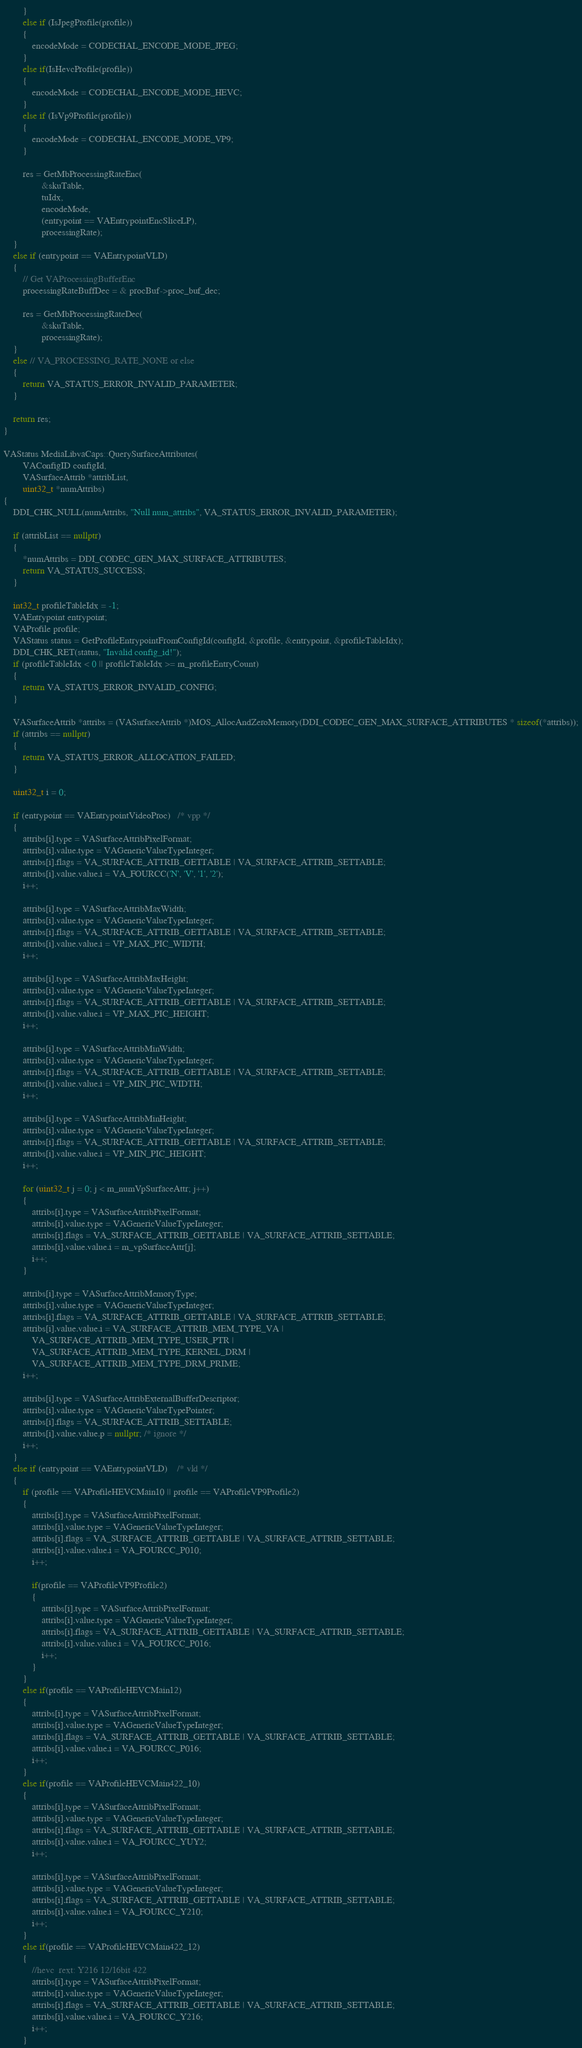Convert code to text. <code><loc_0><loc_0><loc_500><loc_500><_C++_>        }
        else if (IsJpegProfile(profile))
        {
            encodeMode = CODECHAL_ENCODE_MODE_JPEG;
        }
        else if(IsHevcProfile(profile))
        {
            encodeMode = CODECHAL_ENCODE_MODE_HEVC;
        }
        else if (IsVp9Profile(profile))
        {
            encodeMode = CODECHAL_ENCODE_MODE_VP9;
        }

        res = GetMbProcessingRateEnc(
                &skuTable,
                tuIdx,
                encodeMode,
                (entrypoint == VAEntrypointEncSliceLP),
                processingRate);
    }
    else if (entrypoint == VAEntrypointVLD)
    {
        // Get VAProcessingBufferEnc
        processingRateBuffDec = & procBuf->proc_buf_dec;

        res = GetMbProcessingRateDec(
                &skuTable,
                processingRate);
    }
    else // VA_PROCESSING_RATE_NONE or else
    {
        return VA_STATUS_ERROR_INVALID_PARAMETER;
    }

    return res;
}

VAStatus MediaLibvaCaps::QuerySurfaceAttributes(
        VAConfigID configId,
        VASurfaceAttrib *attribList,
        uint32_t *numAttribs)
{
    DDI_CHK_NULL(numAttribs, "Null num_attribs", VA_STATUS_ERROR_INVALID_PARAMETER);

    if (attribList == nullptr)
    {
        *numAttribs = DDI_CODEC_GEN_MAX_SURFACE_ATTRIBUTES;
        return VA_STATUS_SUCCESS;
    }

    int32_t profileTableIdx = -1;
    VAEntrypoint entrypoint;
    VAProfile profile;
    VAStatus status = GetProfileEntrypointFromConfigId(configId, &profile, &entrypoint, &profileTableIdx);
    DDI_CHK_RET(status, "Invalid config_id!");
    if (profileTableIdx < 0 || profileTableIdx >= m_profileEntryCount)
    {
        return VA_STATUS_ERROR_INVALID_CONFIG;
    }

    VASurfaceAttrib *attribs = (VASurfaceAttrib *)MOS_AllocAndZeroMemory(DDI_CODEC_GEN_MAX_SURFACE_ATTRIBUTES * sizeof(*attribs));
    if (attribs == nullptr)
    {
        return VA_STATUS_ERROR_ALLOCATION_FAILED;
    }

    uint32_t i = 0;

    if (entrypoint == VAEntrypointVideoProc)   /* vpp */
    {
        attribs[i].type = VASurfaceAttribPixelFormat;
        attribs[i].value.type = VAGenericValueTypeInteger;
        attribs[i].flags = VA_SURFACE_ATTRIB_GETTABLE | VA_SURFACE_ATTRIB_SETTABLE;
        attribs[i].value.value.i = VA_FOURCC('N', 'V', '1', '2');
        i++;

        attribs[i].type = VASurfaceAttribMaxWidth;
        attribs[i].value.type = VAGenericValueTypeInteger;
        attribs[i].flags = VA_SURFACE_ATTRIB_GETTABLE | VA_SURFACE_ATTRIB_SETTABLE;
        attribs[i].value.value.i = VP_MAX_PIC_WIDTH;
        i++;

        attribs[i].type = VASurfaceAttribMaxHeight;
        attribs[i].value.type = VAGenericValueTypeInteger;
        attribs[i].flags = VA_SURFACE_ATTRIB_GETTABLE | VA_SURFACE_ATTRIB_SETTABLE;
        attribs[i].value.value.i = VP_MAX_PIC_HEIGHT;
        i++;

        attribs[i].type = VASurfaceAttribMinWidth;
        attribs[i].value.type = VAGenericValueTypeInteger;
        attribs[i].flags = VA_SURFACE_ATTRIB_GETTABLE | VA_SURFACE_ATTRIB_SETTABLE;
        attribs[i].value.value.i = VP_MIN_PIC_WIDTH;
        i++;

        attribs[i].type = VASurfaceAttribMinHeight;
        attribs[i].value.type = VAGenericValueTypeInteger;
        attribs[i].flags = VA_SURFACE_ATTRIB_GETTABLE | VA_SURFACE_ATTRIB_SETTABLE;
        attribs[i].value.value.i = VP_MIN_PIC_HEIGHT;
        i++;

        for (uint32_t j = 0; j < m_numVpSurfaceAttr; j++)
        {
            attribs[i].type = VASurfaceAttribPixelFormat;
            attribs[i].value.type = VAGenericValueTypeInteger;
            attribs[i].flags = VA_SURFACE_ATTRIB_GETTABLE | VA_SURFACE_ATTRIB_SETTABLE;
            attribs[i].value.value.i = m_vpSurfaceAttr[j];
            i++;
        }

        attribs[i].type = VASurfaceAttribMemoryType;
        attribs[i].value.type = VAGenericValueTypeInteger;
        attribs[i].flags = VA_SURFACE_ATTRIB_GETTABLE | VA_SURFACE_ATTRIB_SETTABLE;
        attribs[i].value.value.i = VA_SURFACE_ATTRIB_MEM_TYPE_VA |
            VA_SURFACE_ATTRIB_MEM_TYPE_USER_PTR |
            VA_SURFACE_ATTRIB_MEM_TYPE_KERNEL_DRM |
            VA_SURFACE_ATTRIB_MEM_TYPE_DRM_PRIME;
        i++;

        attribs[i].type = VASurfaceAttribExternalBufferDescriptor;
        attribs[i].value.type = VAGenericValueTypePointer;
        attribs[i].flags = VA_SURFACE_ATTRIB_SETTABLE;
        attribs[i].value.value.p = nullptr; /* ignore */
        i++;
    }
    else if (entrypoint == VAEntrypointVLD)    /* vld */
    {
        if (profile == VAProfileHEVCMain10 || profile == VAProfileVP9Profile2)
        {
            attribs[i].type = VASurfaceAttribPixelFormat;
            attribs[i].value.type = VAGenericValueTypeInteger;
            attribs[i].flags = VA_SURFACE_ATTRIB_GETTABLE | VA_SURFACE_ATTRIB_SETTABLE;
            attribs[i].value.value.i = VA_FOURCC_P010;
            i++;

            if(profile == VAProfileVP9Profile2)
            {
                attribs[i].type = VASurfaceAttribPixelFormat;
                attribs[i].value.type = VAGenericValueTypeInteger;
                attribs[i].flags = VA_SURFACE_ATTRIB_GETTABLE | VA_SURFACE_ATTRIB_SETTABLE;
                attribs[i].value.value.i = VA_FOURCC_P016;
                i++;
            }
        }
        else if(profile == VAProfileHEVCMain12)
        {
            attribs[i].type = VASurfaceAttribPixelFormat;
            attribs[i].value.type = VAGenericValueTypeInteger;
            attribs[i].flags = VA_SURFACE_ATTRIB_GETTABLE | VA_SURFACE_ATTRIB_SETTABLE;
            attribs[i].value.value.i = VA_FOURCC_P016;
            i++;
        }
        else if(profile == VAProfileHEVCMain422_10)
        {
            attribs[i].type = VASurfaceAttribPixelFormat;
            attribs[i].value.type = VAGenericValueTypeInteger;
            attribs[i].flags = VA_SURFACE_ATTRIB_GETTABLE | VA_SURFACE_ATTRIB_SETTABLE;
            attribs[i].value.value.i = VA_FOURCC_YUY2;
            i++;

            attribs[i].type = VASurfaceAttribPixelFormat;
            attribs[i].value.type = VAGenericValueTypeInteger;
            attribs[i].flags = VA_SURFACE_ATTRIB_GETTABLE | VA_SURFACE_ATTRIB_SETTABLE;
            attribs[i].value.value.i = VA_FOURCC_Y210;
            i++;
        }
        else if(profile == VAProfileHEVCMain422_12)
        {
            //hevc  rext: Y216 12/16bit 422
            attribs[i].type = VASurfaceAttribPixelFormat;
            attribs[i].value.type = VAGenericValueTypeInteger;
            attribs[i].flags = VA_SURFACE_ATTRIB_GETTABLE | VA_SURFACE_ATTRIB_SETTABLE;
            attribs[i].value.value.i = VA_FOURCC_Y216;
            i++;
        }</code> 